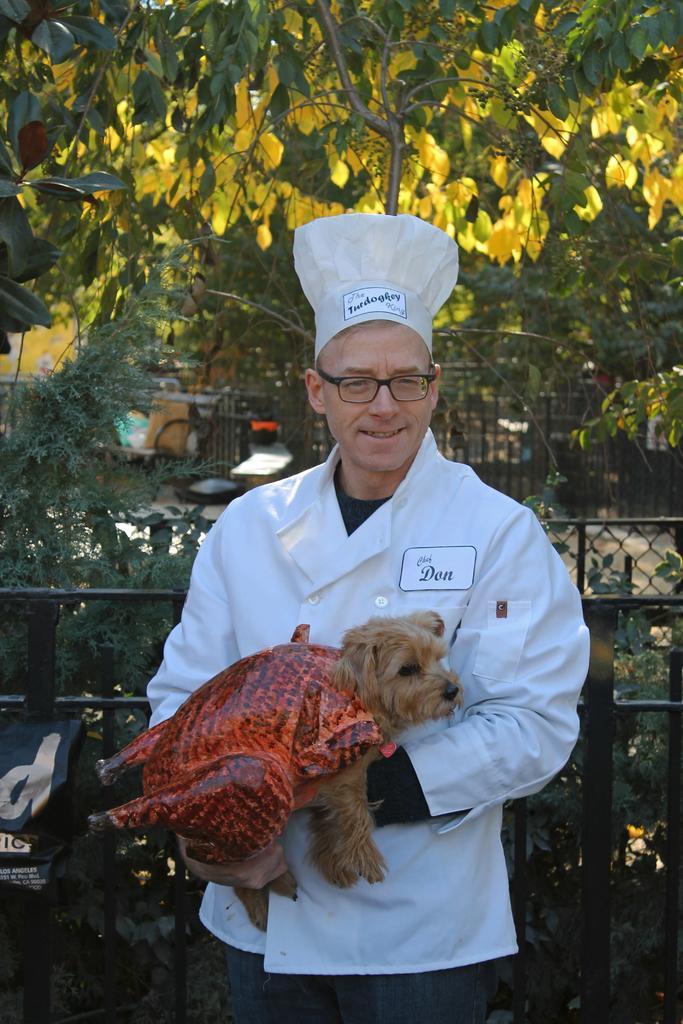Can you describe this image briefly? In this image, a person is standing and holding a dog in his hand and having a smile on his face. In the background top, trees are visible. At the bottom, a fence is visible and some plants are visible. This image is taken in a park during day time. 